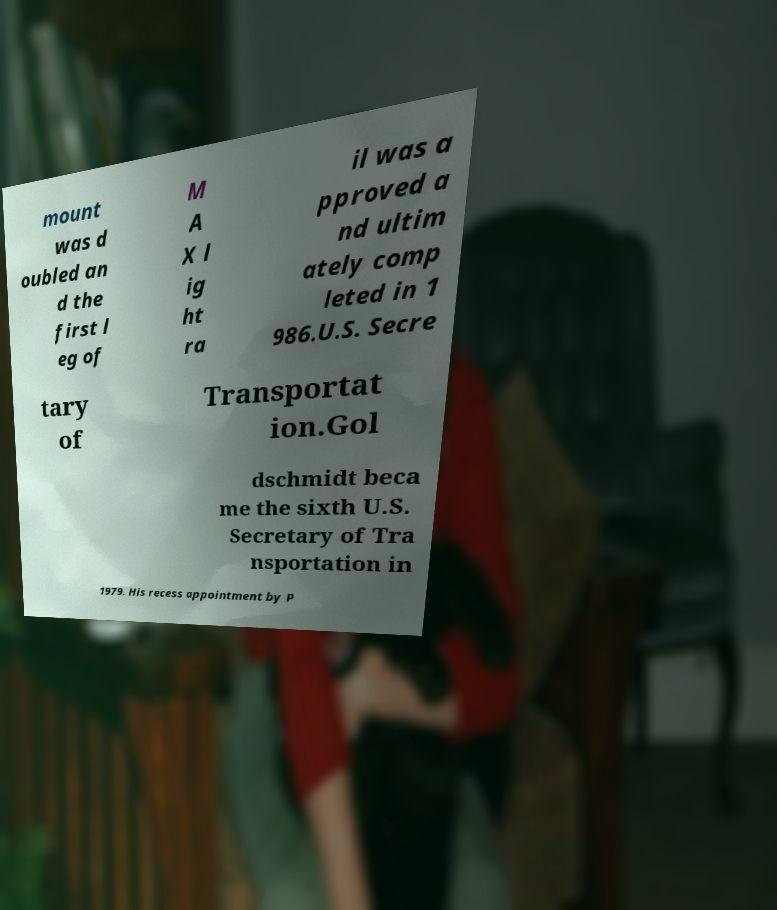Could you extract and type out the text from this image? mount was d oubled an d the first l eg of M A X l ig ht ra il was a pproved a nd ultim ately comp leted in 1 986.U.S. Secre tary of Transportat ion.Gol dschmidt beca me the sixth U.S. Secretary of Tra nsportation in 1979. His recess appointment by P 